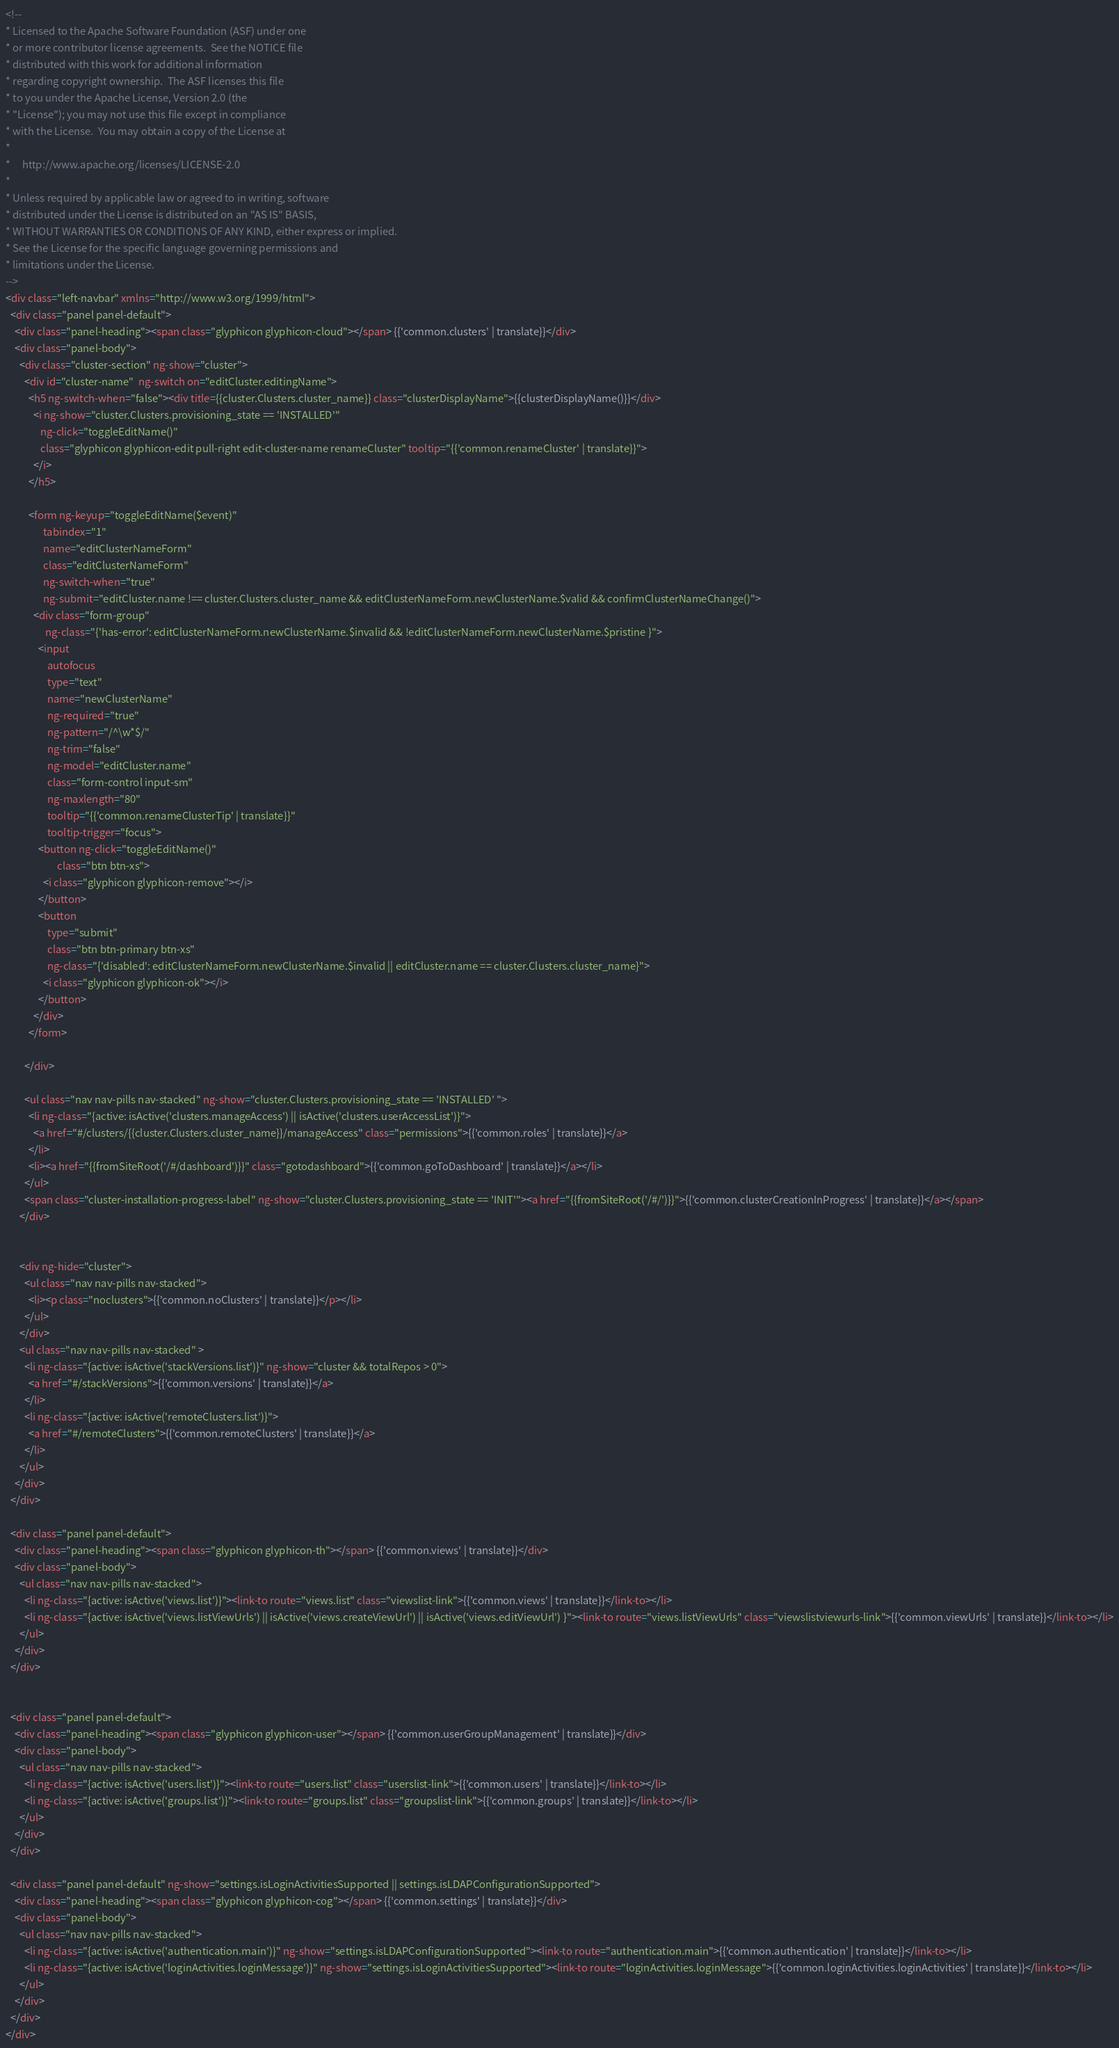Convert code to text. <code><loc_0><loc_0><loc_500><loc_500><_HTML_><!--
* Licensed to the Apache Software Foundation (ASF) under one
* or more contributor license agreements.  See the NOTICE file
* distributed with this work for additional information
* regarding copyright ownership.  The ASF licenses this file
* to you under the Apache License, Version 2.0 (the
* "License"); you may not use this file except in compliance
* with the License.  You may obtain a copy of the License at
*
*     http://www.apache.org/licenses/LICENSE-2.0
*
* Unless required by applicable law or agreed to in writing, software
* distributed under the License is distributed on an "AS IS" BASIS,
* WITHOUT WARRANTIES OR CONDITIONS OF ANY KIND, either express or implied.
* See the License for the specific language governing permissions and
* limitations under the License.
-->
<div class="left-navbar" xmlns="http://www.w3.org/1999/html">
  <div class="panel panel-default">
    <div class="panel-heading"><span class="glyphicon glyphicon-cloud"></span> {{'common.clusters' | translate}}</div>
    <div class="panel-body">
      <div class="cluster-section" ng-show="cluster">
        <div id="cluster-name"  ng-switch on="editCluster.editingName">
          <h5 ng-switch-when="false"><div title={{cluster.Clusters.cluster_name}} class="clusterDisplayName">{{clusterDisplayName()}}</div>
            <i ng-show="cluster.Clusters.provisioning_state == 'INSTALLED'"
               ng-click="toggleEditName()"
               class="glyphicon glyphicon-edit pull-right edit-cluster-name renameCluster" tooltip="{{'common.renameCluster' | translate}}">
            </i>
          </h5>

          <form ng-keyup="toggleEditName($event)"
                tabindex="1"
                name="editClusterNameForm"
                class="editClusterNameForm"
                ng-switch-when="true"
                ng-submit="editCluster.name !== cluster.Clusters.cluster_name && editClusterNameForm.newClusterName.$valid && confirmClusterNameChange()">
            <div class="form-group"
                 ng-class="{'has-error': editClusterNameForm.newClusterName.$invalid && !editClusterNameForm.newClusterName.$pristine }">
              <input
                  autofocus
                  type="text"
                  name="newClusterName"
                  ng-required="true"
                  ng-pattern="/^\w*$/"
                  ng-trim="false"
                  ng-model="editCluster.name"
                  class="form-control input-sm"
                  ng-maxlength="80"
                  tooltip="{{'common.renameClusterTip' | translate}}"
                  tooltip-trigger="focus">
              <button ng-click="toggleEditName()"
                      class="btn btn-xs">
                <i class="glyphicon glyphicon-remove"></i>
              </button>
              <button
                  type="submit"
                  class="btn btn-primary btn-xs"
                  ng-class="{'disabled': editClusterNameForm.newClusterName.$invalid || editCluster.name == cluster.Clusters.cluster_name}">
                <i class="glyphicon glyphicon-ok"></i>
              </button>
            </div>
          </form>

        </div>

        <ul class="nav nav-pills nav-stacked" ng-show="cluster.Clusters.provisioning_state == 'INSTALLED' ">
          <li ng-class="{active: isActive('clusters.manageAccess') || isActive('clusters.userAccessList')}">
            <a href="#/clusters/{{cluster.Clusters.cluster_name}}/manageAccess" class="permissions">{{'common.roles' | translate}}</a>
          </li>
          <li><a href="{{fromSiteRoot('/#/dashboard')}}" class="gotodashboard">{{'common.goToDashboard' | translate}}</a></li>
        </ul>
        <span class="cluster-installation-progress-label" ng-show="cluster.Clusters.provisioning_state == 'INIT'"><a href="{{fromSiteRoot('/#/')}}">{{'common.clusterCreationInProgress' | translate}}</a></span>
      </div>


      <div ng-hide="cluster">
        <ul class="nav nav-pills nav-stacked">
          <li><p class="noclusters">{{'common.noClusters' | translate}}</p></li>
        </ul>
      </div>
      <ul class="nav nav-pills nav-stacked" >
        <li ng-class="{active: isActive('stackVersions.list')}" ng-show="cluster && totalRepos > 0">
          <a href="#/stackVersions">{{'common.versions' | translate}}</a>
        </li>
        <li ng-class="{active: isActive('remoteClusters.list')}">
          <a href="#/remoteClusters">{{'common.remoteClusters' | translate}}</a>
        </li>
      </ul>
    </div>
  </div>

  <div class="panel panel-default">
    <div class="panel-heading"><span class="glyphicon glyphicon-th"></span> {{'common.views' | translate}}</div>
    <div class="panel-body">
      <ul class="nav nav-pills nav-stacked">
        <li ng-class="{active: isActive('views.list')}"><link-to route="views.list" class="viewslist-link">{{'common.views' | translate}}</link-to></li>
        <li ng-class="{active: isActive('views.listViewUrls') || isActive('views.createViewUrl') || isActive('views.editViewUrl') }"><link-to route="views.listViewUrls" class="viewslistviewurls-link">{{'common.viewUrls' | translate}}</link-to></li>
      </ul>
    </div>
  </div>


  <div class="panel panel-default">
    <div class="panel-heading"><span class="glyphicon glyphicon-user"></span> {{'common.userGroupManagement' | translate}}</div>
    <div class="panel-body">
      <ul class="nav nav-pills nav-stacked">
        <li ng-class="{active: isActive('users.list')}"><link-to route="users.list" class="userslist-link">{{'common.users' | translate}}</link-to></li>
        <li ng-class="{active: isActive('groups.list')}"><link-to route="groups.list" class="groupslist-link">{{'common.groups' | translate}}</link-to></li>
      </ul>
    </div>
  </div>

  <div class="panel panel-default" ng-show="settings.isLoginActivitiesSupported || settings.isLDAPConfigurationSupported">
    <div class="panel-heading"><span class="glyphicon glyphicon-cog"></span> {{'common.settings' | translate}}</div>
    <div class="panel-body">
      <ul class="nav nav-pills nav-stacked">
        <li ng-class="{active: isActive('authentication.main')}" ng-show="settings.isLDAPConfigurationSupported"><link-to route="authentication.main">{{'common.authentication' | translate}}</link-to></li>
        <li ng-class="{active: isActive('loginActivities.loginMessage')}" ng-show="settings.isLoginActivitiesSupported"><link-to route="loginActivities.loginMessage">{{'common.loginActivities.loginActivities' | translate}}</link-to></li>
      </ul>
    </div>
  </div>
</div>

</code> 